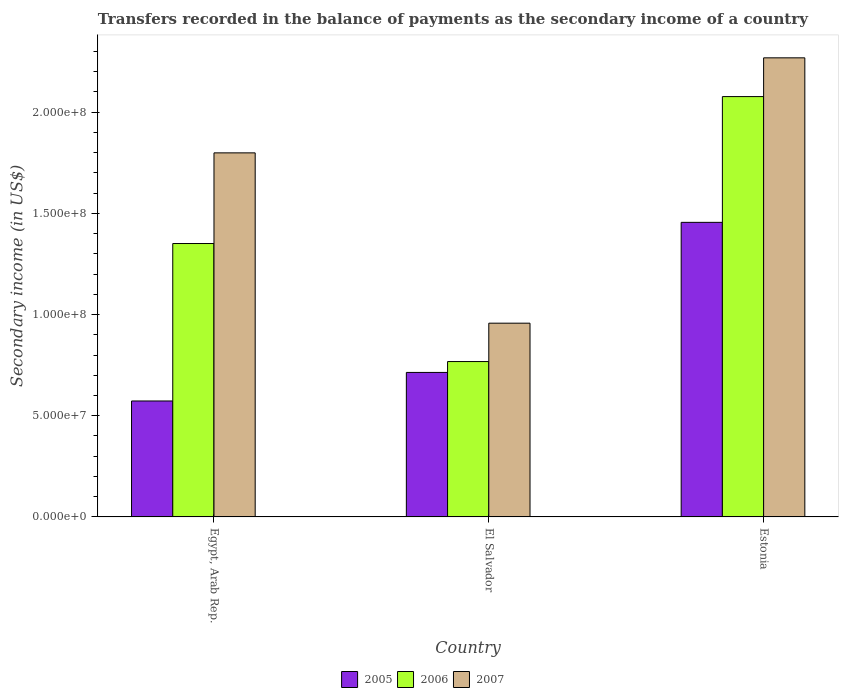Are the number of bars on each tick of the X-axis equal?
Ensure brevity in your answer.  Yes. How many bars are there on the 1st tick from the right?
Offer a terse response. 3. What is the label of the 3rd group of bars from the left?
Give a very brief answer. Estonia. What is the secondary income of in 2005 in Estonia?
Your answer should be very brief. 1.46e+08. Across all countries, what is the maximum secondary income of in 2007?
Your response must be concise. 2.27e+08. Across all countries, what is the minimum secondary income of in 2006?
Offer a terse response. 7.68e+07. In which country was the secondary income of in 2007 maximum?
Your answer should be compact. Estonia. In which country was the secondary income of in 2007 minimum?
Ensure brevity in your answer.  El Salvador. What is the total secondary income of in 2005 in the graph?
Make the answer very short. 2.74e+08. What is the difference between the secondary income of in 2006 in Egypt, Arab Rep. and that in El Salvador?
Make the answer very short. 5.83e+07. What is the difference between the secondary income of in 2007 in Estonia and the secondary income of in 2006 in El Salvador?
Provide a short and direct response. 1.50e+08. What is the average secondary income of in 2006 per country?
Provide a short and direct response. 1.40e+08. What is the difference between the secondary income of of/in 2005 and secondary income of of/in 2007 in Egypt, Arab Rep.?
Your answer should be very brief. -1.23e+08. What is the ratio of the secondary income of in 2007 in El Salvador to that in Estonia?
Provide a short and direct response. 0.42. What is the difference between the highest and the second highest secondary income of in 2006?
Provide a succinct answer. 5.83e+07. What is the difference between the highest and the lowest secondary income of in 2007?
Your answer should be compact. 1.31e+08. Is the sum of the secondary income of in 2005 in Egypt, Arab Rep. and Estonia greater than the maximum secondary income of in 2006 across all countries?
Offer a terse response. No. What does the 2nd bar from the left in Estonia represents?
Keep it short and to the point. 2006. Is it the case that in every country, the sum of the secondary income of in 2007 and secondary income of in 2005 is greater than the secondary income of in 2006?
Offer a terse response. Yes. How many bars are there?
Ensure brevity in your answer.  9. Are all the bars in the graph horizontal?
Keep it short and to the point. No. How many countries are there in the graph?
Your response must be concise. 3. What is the difference between two consecutive major ticks on the Y-axis?
Your response must be concise. 5.00e+07. How are the legend labels stacked?
Provide a short and direct response. Horizontal. What is the title of the graph?
Your answer should be very brief. Transfers recorded in the balance of payments as the secondary income of a country. What is the label or title of the X-axis?
Make the answer very short. Country. What is the label or title of the Y-axis?
Offer a very short reply. Secondary income (in US$). What is the Secondary income (in US$) in 2005 in Egypt, Arab Rep.?
Your answer should be compact. 5.73e+07. What is the Secondary income (in US$) in 2006 in Egypt, Arab Rep.?
Offer a terse response. 1.35e+08. What is the Secondary income (in US$) in 2007 in Egypt, Arab Rep.?
Offer a terse response. 1.80e+08. What is the Secondary income (in US$) of 2005 in El Salvador?
Keep it short and to the point. 7.14e+07. What is the Secondary income (in US$) in 2006 in El Salvador?
Your answer should be very brief. 7.68e+07. What is the Secondary income (in US$) of 2007 in El Salvador?
Your answer should be very brief. 9.57e+07. What is the Secondary income (in US$) in 2005 in Estonia?
Your answer should be very brief. 1.46e+08. What is the Secondary income (in US$) in 2006 in Estonia?
Offer a terse response. 2.08e+08. What is the Secondary income (in US$) in 2007 in Estonia?
Your answer should be very brief. 2.27e+08. Across all countries, what is the maximum Secondary income (in US$) of 2005?
Your response must be concise. 1.46e+08. Across all countries, what is the maximum Secondary income (in US$) of 2006?
Ensure brevity in your answer.  2.08e+08. Across all countries, what is the maximum Secondary income (in US$) of 2007?
Offer a very short reply. 2.27e+08. Across all countries, what is the minimum Secondary income (in US$) in 2005?
Your response must be concise. 5.73e+07. Across all countries, what is the minimum Secondary income (in US$) of 2006?
Ensure brevity in your answer.  7.68e+07. Across all countries, what is the minimum Secondary income (in US$) in 2007?
Give a very brief answer. 9.57e+07. What is the total Secondary income (in US$) in 2005 in the graph?
Provide a succinct answer. 2.74e+08. What is the total Secondary income (in US$) of 2006 in the graph?
Provide a succinct answer. 4.20e+08. What is the total Secondary income (in US$) of 2007 in the graph?
Provide a short and direct response. 5.02e+08. What is the difference between the Secondary income (in US$) in 2005 in Egypt, Arab Rep. and that in El Salvador?
Offer a very short reply. -1.41e+07. What is the difference between the Secondary income (in US$) of 2006 in Egypt, Arab Rep. and that in El Salvador?
Keep it short and to the point. 5.83e+07. What is the difference between the Secondary income (in US$) in 2007 in Egypt, Arab Rep. and that in El Salvador?
Your answer should be very brief. 8.42e+07. What is the difference between the Secondary income (in US$) in 2005 in Egypt, Arab Rep. and that in Estonia?
Ensure brevity in your answer.  -8.83e+07. What is the difference between the Secondary income (in US$) in 2006 in Egypt, Arab Rep. and that in Estonia?
Make the answer very short. -7.26e+07. What is the difference between the Secondary income (in US$) in 2007 in Egypt, Arab Rep. and that in Estonia?
Your response must be concise. -4.70e+07. What is the difference between the Secondary income (in US$) in 2005 in El Salvador and that in Estonia?
Keep it short and to the point. -7.42e+07. What is the difference between the Secondary income (in US$) in 2006 in El Salvador and that in Estonia?
Provide a succinct answer. -1.31e+08. What is the difference between the Secondary income (in US$) of 2007 in El Salvador and that in Estonia?
Give a very brief answer. -1.31e+08. What is the difference between the Secondary income (in US$) of 2005 in Egypt, Arab Rep. and the Secondary income (in US$) of 2006 in El Salvador?
Offer a very short reply. -1.95e+07. What is the difference between the Secondary income (in US$) of 2005 in Egypt, Arab Rep. and the Secondary income (in US$) of 2007 in El Salvador?
Provide a succinct answer. -3.84e+07. What is the difference between the Secondary income (in US$) of 2006 in Egypt, Arab Rep. and the Secondary income (in US$) of 2007 in El Salvador?
Provide a short and direct response. 3.94e+07. What is the difference between the Secondary income (in US$) in 2005 in Egypt, Arab Rep. and the Secondary income (in US$) in 2006 in Estonia?
Your answer should be very brief. -1.50e+08. What is the difference between the Secondary income (in US$) of 2005 in Egypt, Arab Rep. and the Secondary income (in US$) of 2007 in Estonia?
Your answer should be compact. -1.70e+08. What is the difference between the Secondary income (in US$) of 2006 in Egypt, Arab Rep. and the Secondary income (in US$) of 2007 in Estonia?
Provide a short and direct response. -9.18e+07. What is the difference between the Secondary income (in US$) of 2005 in El Salvador and the Secondary income (in US$) of 2006 in Estonia?
Your response must be concise. -1.36e+08. What is the difference between the Secondary income (in US$) of 2005 in El Salvador and the Secondary income (in US$) of 2007 in Estonia?
Offer a terse response. -1.55e+08. What is the difference between the Secondary income (in US$) in 2006 in El Salvador and the Secondary income (in US$) in 2007 in Estonia?
Make the answer very short. -1.50e+08. What is the average Secondary income (in US$) of 2005 per country?
Keep it short and to the point. 9.14e+07. What is the average Secondary income (in US$) in 2006 per country?
Provide a succinct answer. 1.40e+08. What is the average Secondary income (in US$) in 2007 per country?
Provide a short and direct response. 1.67e+08. What is the difference between the Secondary income (in US$) in 2005 and Secondary income (in US$) in 2006 in Egypt, Arab Rep.?
Your answer should be very brief. -7.78e+07. What is the difference between the Secondary income (in US$) in 2005 and Secondary income (in US$) in 2007 in Egypt, Arab Rep.?
Keep it short and to the point. -1.23e+08. What is the difference between the Secondary income (in US$) in 2006 and Secondary income (in US$) in 2007 in Egypt, Arab Rep.?
Offer a very short reply. -4.48e+07. What is the difference between the Secondary income (in US$) in 2005 and Secondary income (in US$) in 2006 in El Salvador?
Your answer should be compact. -5.38e+06. What is the difference between the Secondary income (in US$) of 2005 and Secondary income (in US$) of 2007 in El Salvador?
Your answer should be very brief. -2.43e+07. What is the difference between the Secondary income (in US$) in 2006 and Secondary income (in US$) in 2007 in El Salvador?
Your answer should be very brief. -1.90e+07. What is the difference between the Secondary income (in US$) of 2005 and Secondary income (in US$) of 2006 in Estonia?
Provide a short and direct response. -6.21e+07. What is the difference between the Secondary income (in US$) in 2005 and Secondary income (in US$) in 2007 in Estonia?
Your answer should be very brief. -8.13e+07. What is the difference between the Secondary income (in US$) of 2006 and Secondary income (in US$) of 2007 in Estonia?
Offer a very short reply. -1.92e+07. What is the ratio of the Secondary income (in US$) of 2005 in Egypt, Arab Rep. to that in El Salvador?
Make the answer very short. 0.8. What is the ratio of the Secondary income (in US$) in 2006 in Egypt, Arab Rep. to that in El Salvador?
Your answer should be very brief. 1.76. What is the ratio of the Secondary income (in US$) of 2007 in Egypt, Arab Rep. to that in El Salvador?
Provide a succinct answer. 1.88. What is the ratio of the Secondary income (in US$) of 2005 in Egypt, Arab Rep. to that in Estonia?
Your answer should be compact. 0.39. What is the ratio of the Secondary income (in US$) in 2006 in Egypt, Arab Rep. to that in Estonia?
Offer a terse response. 0.65. What is the ratio of the Secondary income (in US$) in 2007 in Egypt, Arab Rep. to that in Estonia?
Provide a short and direct response. 0.79. What is the ratio of the Secondary income (in US$) in 2005 in El Salvador to that in Estonia?
Provide a short and direct response. 0.49. What is the ratio of the Secondary income (in US$) in 2006 in El Salvador to that in Estonia?
Your response must be concise. 0.37. What is the ratio of the Secondary income (in US$) in 2007 in El Salvador to that in Estonia?
Provide a succinct answer. 0.42. What is the difference between the highest and the second highest Secondary income (in US$) in 2005?
Your response must be concise. 7.42e+07. What is the difference between the highest and the second highest Secondary income (in US$) in 2006?
Offer a terse response. 7.26e+07. What is the difference between the highest and the second highest Secondary income (in US$) in 2007?
Your answer should be compact. 4.70e+07. What is the difference between the highest and the lowest Secondary income (in US$) of 2005?
Provide a short and direct response. 8.83e+07. What is the difference between the highest and the lowest Secondary income (in US$) of 2006?
Provide a succinct answer. 1.31e+08. What is the difference between the highest and the lowest Secondary income (in US$) of 2007?
Offer a very short reply. 1.31e+08. 